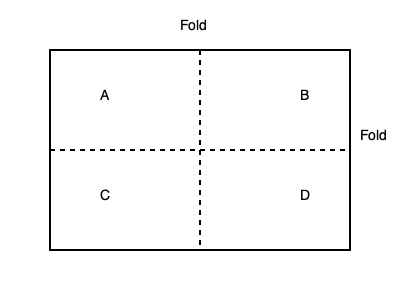The diagram represents an unfolded first aid kit box. If the box is folded along the dotted lines, which two sections will form the top of the box? To determine which sections will form the top of the box when folded, we need to follow these steps:

1. Identify the sections: The diagram shows four sections labeled A, B, C, and D.

2. Understand the folding lines: There are two dotted lines indicating where to fold - one vertical and one horizontal.

3. Visualize the folding process:
   a. The horizontal fold will bring the top half (sections A and B) towards the bottom half (sections C and D).
   b. The vertical fold will bring the right half (sections B and D) towards the left half (sections A and C).

4. Determine the final position:
   a. When folded, sections A and B will be on top of sections C and D, respectively.
   b. The vertical fold will then bring B over A, and D over C.

5. Identify the top of the box:
   After folding, section B will be on the very top, covering section A.

Therefore, sections A and B will form the top of the box when folded.
Answer: A and B 